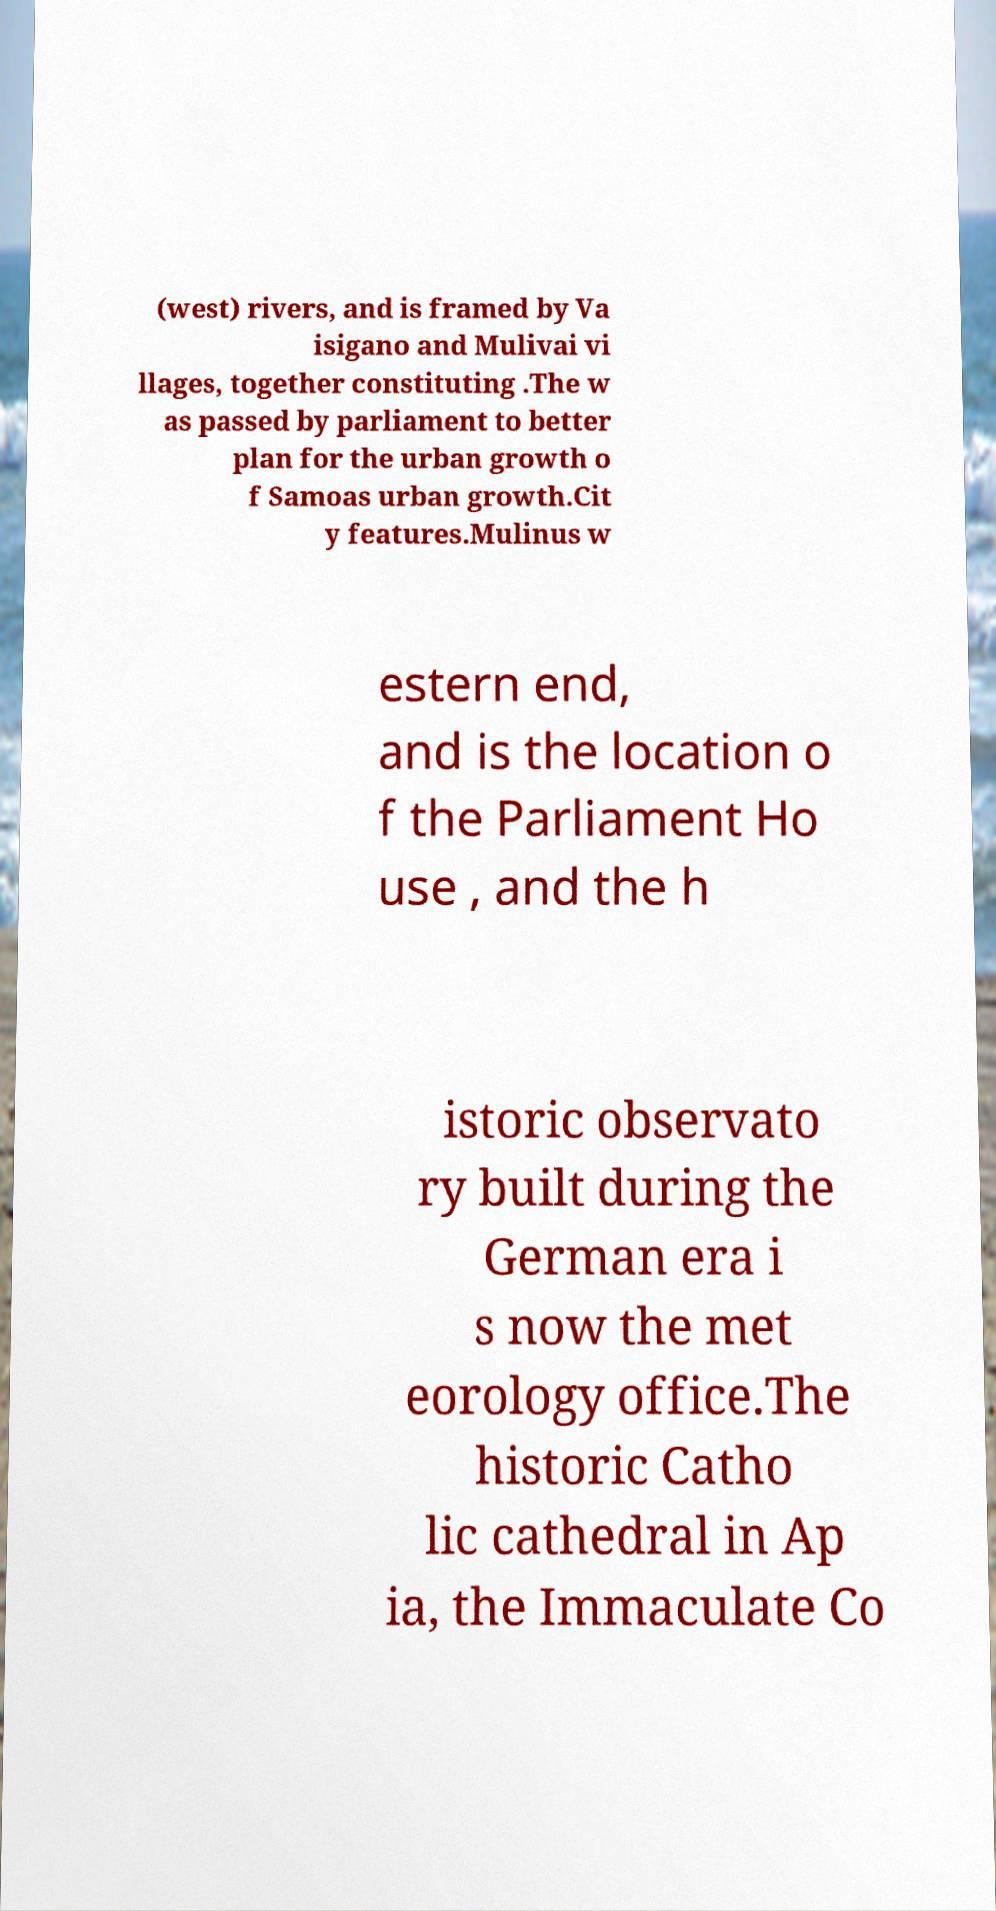Please identify and transcribe the text found in this image. (west) rivers, and is framed by Va isigano and Mulivai vi llages, together constituting .The w as passed by parliament to better plan for the urban growth o f Samoas urban growth.Cit y features.Mulinus w estern end, and is the location o f the Parliament Ho use , and the h istoric observato ry built during the German era i s now the met eorology office.The historic Catho lic cathedral in Ap ia, the Immaculate Co 